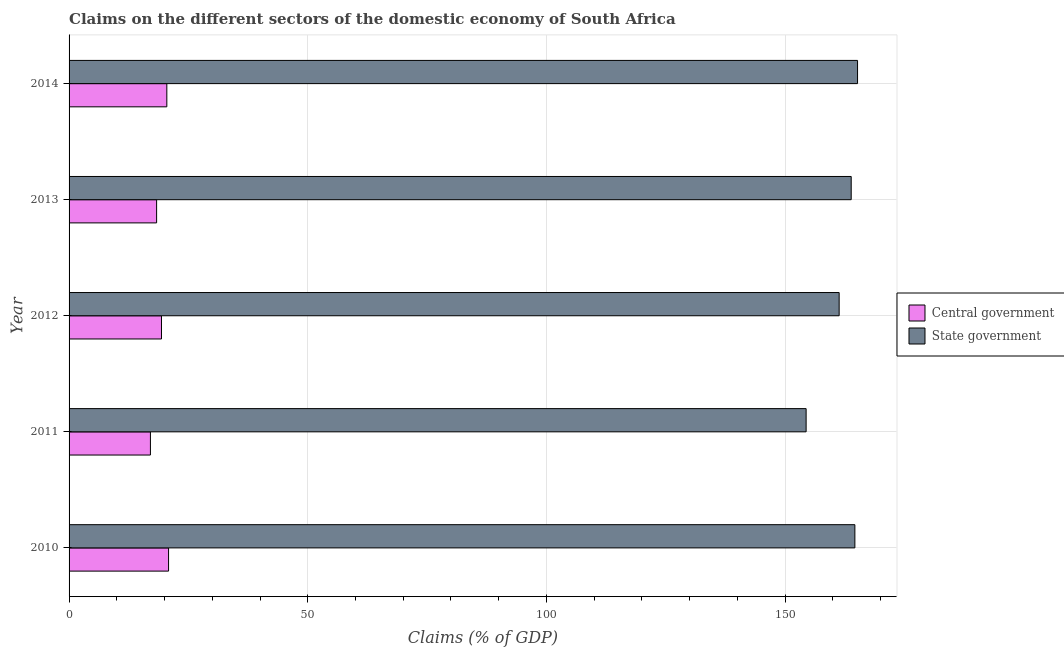Are the number of bars per tick equal to the number of legend labels?
Your answer should be very brief. Yes. Are the number of bars on each tick of the Y-axis equal?
Ensure brevity in your answer.  Yes. How many bars are there on the 4th tick from the top?
Keep it short and to the point. 2. How many bars are there on the 5th tick from the bottom?
Give a very brief answer. 2. What is the claims on state government in 2014?
Keep it short and to the point. 165.19. Across all years, what is the maximum claims on central government?
Your answer should be compact. 20.84. Across all years, what is the minimum claims on central government?
Offer a terse response. 17.04. What is the total claims on central government in the graph?
Make the answer very short. 96.07. What is the difference between the claims on state government in 2011 and that in 2014?
Your answer should be compact. -10.77. What is the difference between the claims on state government in 2011 and the claims on central government in 2014?
Give a very brief answer. 133.94. What is the average claims on central government per year?
Your answer should be very brief. 19.21. In the year 2011, what is the difference between the claims on state government and claims on central government?
Provide a succinct answer. 137.38. What is the difference between the highest and the second highest claims on state government?
Give a very brief answer. 0.56. What is the difference between the highest and the lowest claims on state government?
Offer a very short reply. 10.77. What does the 2nd bar from the top in 2014 represents?
Offer a very short reply. Central government. What does the 2nd bar from the bottom in 2010 represents?
Provide a short and direct response. State government. Are the values on the major ticks of X-axis written in scientific E-notation?
Provide a succinct answer. No. What is the title of the graph?
Your response must be concise. Claims on the different sectors of the domestic economy of South Africa. Does "Female" appear as one of the legend labels in the graph?
Give a very brief answer. No. What is the label or title of the X-axis?
Provide a short and direct response. Claims (% of GDP). What is the label or title of the Y-axis?
Offer a very short reply. Year. What is the Claims (% of GDP) of Central government in 2010?
Keep it short and to the point. 20.84. What is the Claims (% of GDP) in State government in 2010?
Provide a succinct answer. 164.63. What is the Claims (% of GDP) of Central government in 2011?
Give a very brief answer. 17.04. What is the Claims (% of GDP) of State government in 2011?
Keep it short and to the point. 154.42. What is the Claims (% of GDP) of Central government in 2012?
Make the answer very short. 19.36. What is the Claims (% of GDP) of State government in 2012?
Keep it short and to the point. 161.34. What is the Claims (% of GDP) in Central government in 2013?
Your response must be concise. 18.34. What is the Claims (% of GDP) in State government in 2013?
Keep it short and to the point. 163.86. What is the Claims (% of GDP) in Central government in 2014?
Ensure brevity in your answer.  20.48. What is the Claims (% of GDP) of State government in 2014?
Keep it short and to the point. 165.19. Across all years, what is the maximum Claims (% of GDP) in Central government?
Ensure brevity in your answer.  20.84. Across all years, what is the maximum Claims (% of GDP) of State government?
Ensure brevity in your answer.  165.19. Across all years, what is the minimum Claims (% of GDP) of Central government?
Make the answer very short. 17.04. Across all years, what is the minimum Claims (% of GDP) in State government?
Offer a terse response. 154.42. What is the total Claims (% of GDP) of Central government in the graph?
Your answer should be compact. 96.07. What is the total Claims (% of GDP) of State government in the graph?
Offer a very short reply. 809.44. What is the difference between the Claims (% of GDP) of State government in 2010 and that in 2011?
Offer a very short reply. 10.21. What is the difference between the Claims (% of GDP) in Central government in 2010 and that in 2012?
Provide a short and direct response. 1.48. What is the difference between the Claims (% of GDP) of State government in 2010 and that in 2012?
Your answer should be compact. 3.29. What is the difference between the Claims (% of GDP) of Central government in 2010 and that in 2013?
Provide a succinct answer. 2.5. What is the difference between the Claims (% of GDP) of State government in 2010 and that in 2013?
Ensure brevity in your answer.  0.77. What is the difference between the Claims (% of GDP) in Central government in 2010 and that in 2014?
Your answer should be compact. 0.36. What is the difference between the Claims (% of GDP) of State government in 2010 and that in 2014?
Keep it short and to the point. -0.56. What is the difference between the Claims (% of GDP) of Central government in 2011 and that in 2012?
Ensure brevity in your answer.  -2.32. What is the difference between the Claims (% of GDP) in State government in 2011 and that in 2012?
Your answer should be very brief. -6.92. What is the difference between the Claims (% of GDP) of Central government in 2011 and that in 2013?
Provide a succinct answer. -1.3. What is the difference between the Claims (% of GDP) in State government in 2011 and that in 2013?
Your answer should be compact. -9.44. What is the difference between the Claims (% of GDP) of Central government in 2011 and that in 2014?
Ensure brevity in your answer.  -3.44. What is the difference between the Claims (% of GDP) of State government in 2011 and that in 2014?
Ensure brevity in your answer.  -10.77. What is the difference between the Claims (% of GDP) of Central government in 2012 and that in 2013?
Give a very brief answer. 1.02. What is the difference between the Claims (% of GDP) in State government in 2012 and that in 2013?
Make the answer very short. -2.52. What is the difference between the Claims (% of GDP) in Central government in 2012 and that in 2014?
Your answer should be compact. -1.12. What is the difference between the Claims (% of GDP) in State government in 2012 and that in 2014?
Keep it short and to the point. -3.85. What is the difference between the Claims (% of GDP) in Central government in 2013 and that in 2014?
Provide a succinct answer. -2.14. What is the difference between the Claims (% of GDP) of State government in 2013 and that in 2014?
Your answer should be compact. -1.33. What is the difference between the Claims (% of GDP) of Central government in 2010 and the Claims (% of GDP) of State government in 2011?
Your response must be concise. -133.57. What is the difference between the Claims (% of GDP) in Central government in 2010 and the Claims (% of GDP) in State government in 2012?
Make the answer very short. -140.49. What is the difference between the Claims (% of GDP) in Central government in 2010 and the Claims (% of GDP) in State government in 2013?
Keep it short and to the point. -143.02. What is the difference between the Claims (% of GDP) of Central government in 2010 and the Claims (% of GDP) of State government in 2014?
Your response must be concise. -144.35. What is the difference between the Claims (% of GDP) of Central government in 2011 and the Claims (% of GDP) of State government in 2012?
Your response must be concise. -144.29. What is the difference between the Claims (% of GDP) in Central government in 2011 and the Claims (% of GDP) in State government in 2013?
Provide a short and direct response. -146.82. What is the difference between the Claims (% of GDP) of Central government in 2011 and the Claims (% of GDP) of State government in 2014?
Give a very brief answer. -148.15. What is the difference between the Claims (% of GDP) of Central government in 2012 and the Claims (% of GDP) of State government in 2013?
Make the answer very short. -144.5. What is the difference between the Claims (% of GDP) in Central government in 2012 and the Claims (% of GDP) in State government in 2014?
Your answer should be very brief. -145.83. What is the difference between the Claims (% of GDP) of Central government in 2013 and the Claims (% of GDP) of State government in 2014?
Your answer should be very brief. -146.85. What is the average Claims (% of GDP) in Central government per year?
Give a very brief answer. 19.21. What is the average Claims (% of GDP) of State government per year?
Make the answer very short. 161.89. In the year 2010, what is the difference between the Claims (% of GDP) in Central government and Claims (% of GDP) in State government?
Your answer should be compact. -143.79. In the year 2011, what is the difference between the Claims (% of GDP) of Central government and Claims (% of GDP) of State government?
Give a very brief answer. -137.37. In the year 2012, what is the difference between the Claims (% of GDP) in Central government and Claims (% of GDP) in State government?
Provide a succinct answer. -141.98. In the year 2013, what is the difference between the Claims (% of GDP) of Central government and Claims (% of GDP) of State government?
Provide a short and direct response. -145.52. In the year 2014, what is the difference between the Claims (% of GDP) in Central government and Claims (% of GDP) in State government?
Your answer should be very brief. -144.71. What is the ratio of the Claims (% of GDP) in Central government in 2010 to that in 2011?
Offer a terse response. 1.22. What is the ratio of the Claims (% of GDP) in State government in 2010 to that in 2011?
Provide a short and direct response. 1.07. What is the ratio of the Claims (% of GDP) of Central government in 2010 to that in 2012?
Your response must be concise. 1.08. What is the ratio of the Claims (% of GDP) in State government in 2010 to that in 2012?
Ensure brevity in your answer.  1.02. What is the ratio of the Claims (% of GDP) of Central government in 2010 to that in 2013?
Provide a succinct answer. 1.14. What is the ratio of the Claims (% of GDP) of Central government in 2010 to that in 2014?
Provide a short and direct response. 1.02. What is the ratio of the Claims (% of GDP) in State government in 2010 to that in 2014?
Make the answer very short. 1. What is the ratio of the Claims (% of GDP) of Central government in 2011 to that in 2012?
Give a very brief answer. 0.88. What is the ratio of the Claims (% of GDP) in State government in 2011 to that in 2012?
Keep it short and to the point. 0.96. What is the ratio of the Claims (% of GDP) of Central government in 2011 to that in 2013?
Ensure brevity in your answer.  0.93. What is the ratio of the Claims (% of GDP) of State government in 2011 to that in 2013?
Your answer should be very brief. 0.94. What is the ratio of the Claims (% of GDP) of Central government in 2011 to that in 2014?
Provide a short and direct response. 0.83. What is the ratio of the Claims (% of GDP) in State government in 2011 to that in 2014?
Your answer should be compact. 0.93. What is the ratio of the Claims (% of GDP) in Central government in 2012 to that in 2013?
Give a very brief answer. 1.06. What is the ratio of the Claims (% of GDP) in State government in 2012 to that in 2013?
Give a very brief answer. 0.98. What is the ratio of the Claims (% of GDP) in Central government in 2012 to that in 2014?
Ensure brevity in your answer.  0.95. What is the ratio of the Claims (% of GDP) of State government in 2012 to that in 2014?
Give a very brief answer. 0.98. What is the ratio of the Claims (% of GDP) in Central government in 2013 to that in 2014?
Your answer should be compact. 0.9. What is the ratio of the Claims (% of GDP) of State government in 2013 to that in 2014?
Your answer should be compact. 0.99. What is the difference between the highest and the second highest Claims (% of GDP) in Central government?
Offer a very short reply. 0.36. What is the difference between the highest and the second highest Claims (% of GDP) in State government?
Make the answer very short. 0.56. What is the difference between the highest and the lowest Claims (% of GDP) of Central government?
Your answer should be compact. 3.8. What is the difference between the highest and the lowest Claims (% of GDP) in State government?
Offer a terse response. 10.77. 